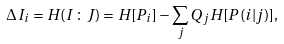<formula> <loc_0><loc_0><loc_500><loc_500>\Delta I _ { i } = H ( I \, \colon \, J ) = H [ P _ { i } ] - \sum _ { j } Q _ { j } H [ P ( i | j ) ] ,</formula> 